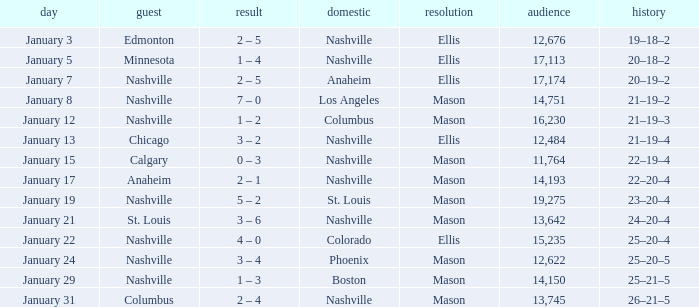On January 29, who had the decision of Mason? Nashville. 